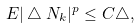<formula> <loc_0><loc_0><loc_500><loc_500>E | \bigtriangleup N _ { k } | ^ { p } \leq C \bigtriangleup ,</formula> 